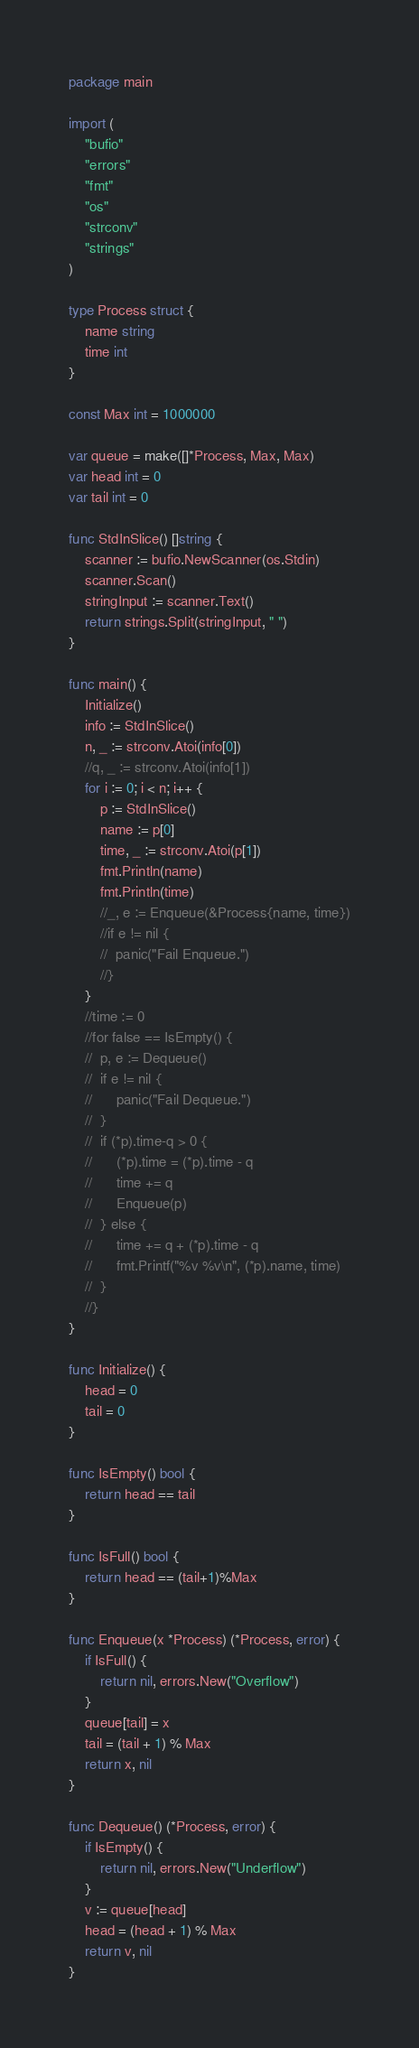<code> <loc_0><loc_0><loc_500><loc_500><_Go_>package main

import (
	"bufio"
	"errors"
	"fmt"
	"os"
	"strconv"
	"strings"
)

type Process struct {
	name string
	time int
}

const Max int = 1000000

var queue = make([]*Process, Max, Max)
var head int = 0
var tail int = 0

func StdInSlice() []string {
	scanner := bufio.NewScanner(os.Stdin)
	scanner.Scan()
	stringInput := scanner.Text()
	return strings.Split(stringInput, " ")
}

func main() {
	Initialize()
	info := StdInSlice()
	n, _ := strconv.Atoi(info[0])
	//q, _ := strconv.Atoi(info[1])
	for i := 0; i < n; i++ {
		p := StdInSlice()
		name := p[0]
		time, _ := strconv.Atoi(p[1])
		fmt.Println(name)
		fmt.Println(time)
		//_, e := Enqueue(&Process{name, time})
		//if e != nil {
		//	panic("Fail Enqueue.")
		//}
	}
	//time := 0
	//for false == IsEmpty() {
	//	p, e := Dequeue()
	//	if e != nil {
	//		panic("Fail Dequeue.")
	//	}
	//	if (*p).time-q > 0 {
	//		(*p).time = (*p).time - q
	//		time += q
	//		Enqueue(p)
	//	} else {
	//		time += q + (*p).time - q
	//		fmt.Printf("%v %v\n", (*p).name, time)
	//	}
	//}
}

func Initialize() {
	head = 0
	tail = 0
}

func IsEmpty() bool {
	return head == tail
}

func IsFull() bool {
	return head == (tail+1)%Max
}

func Enqueue(x *Process) (*Process, error) {
	if IsFull() {
		return nil, errors.New("Overflow")
	}
	queue[tail] = x
	tail = (tail + 1) % Max
	return x, nil
}

func Dequeue() (*Process, error) {
	if IsEmpty() {
		return nil, errors.New("Underflow")
	}
	v := queue[head]
	head = (head + 1) % Max
	return v, nil
}

</code> 